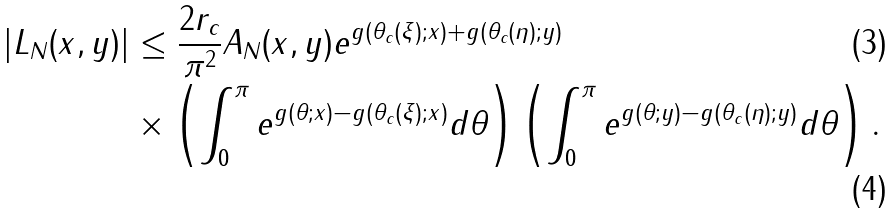Convert formula to latex. <formula><loc_0><loc_0><loc_500><loc_500>| L _ { N } ( x , y ) | & \leq \frac { 2 r _ { c } } { \pi ^ { 2 } } A _ { N } ( x , y ) e ^ { g ( \theta _ { c } ( \xi ) ; x ) + g ( \theta _ { c } ( \eta ) ; y ) } \\ & \times \left ( \int _ { 0 } ^ { \pi } e ^ { g ( \theta ; x ) - g ( \theta _ { c } ( \xi ) ; x ) } d \theta \right ) \left ( \int _ { 0 } ^ { \pi } e ^ { g ( \theta ; y ) - g ( \theta _ { c } ( \eta ) ; y ) } d \theta \right ) .</formula> 